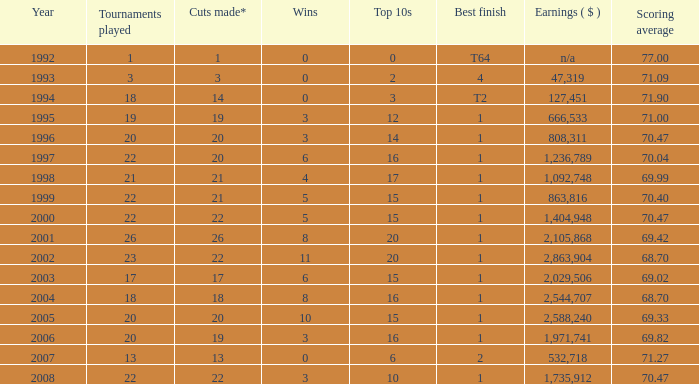Tell me the highest wins for year less than 2000 and best finish of 4 and tournaments played less than 3 None. 